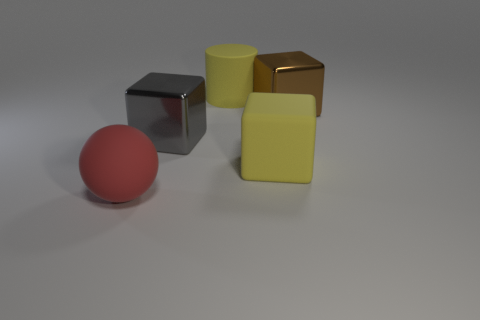Are there fewer blocks on the left side of the large gray cube than yellow rubber objects?
Keep it short and to the point. Yes. There is a matte thing that is behind the large block behind the metal block to the left of the large rubber cube; what color is it?
Your answer should be compact. Yellow. How many shiny objects are either blue spheres or big yellow objects?
Your response must be concise. 0. Does the yellow block have the same size as the red ball?
Give a very brief answer. Yes. Are there fewer large gray cubes that are in front of the matte cylinder than yellow things to the left of the gray shiny object?
Your response must be concise. No. Are there any other things that are the same size as the red ball?
Give a very brief answer. Yes. How big is the brown thing?
Provide a short and direct response. Large. What number of small objects are yellow rubber cylinders or brown metallic objects?
Provide a succinct answer. 0. There is a yellow cylinder; is it the same size as the metallic object left of the yellow rubber block?
Offer a terse response. Yes. Is there anything else that is the same shape as the brown thing?
Your response must be concise. Yes. 